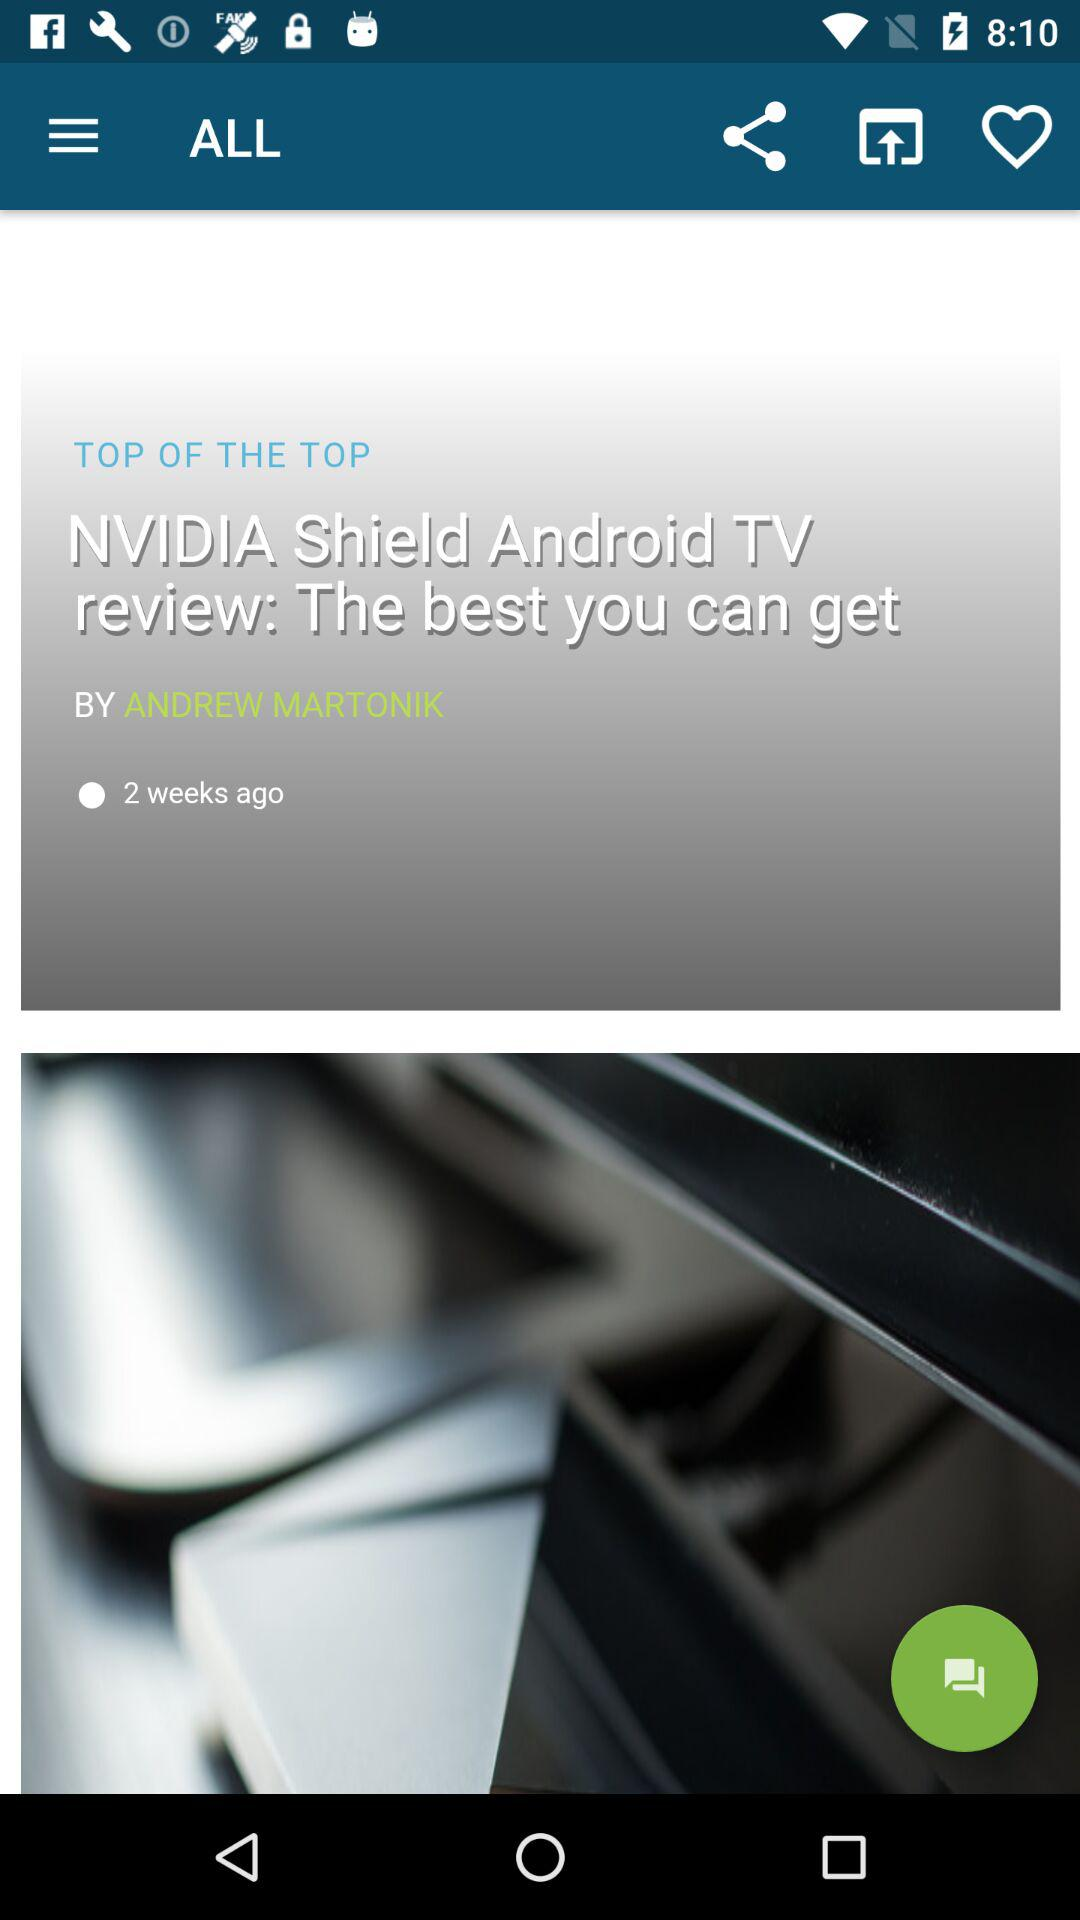When was it published? It was published two weeks ago. 